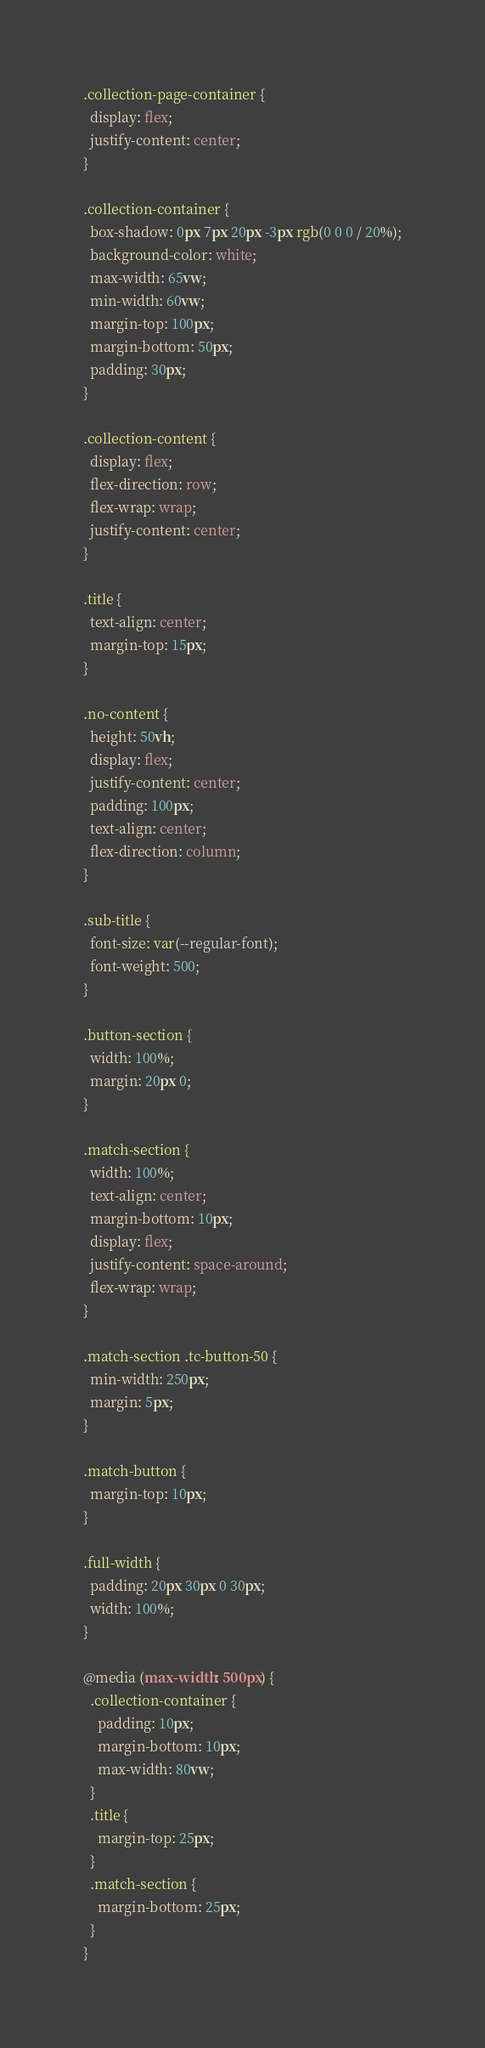<code> <loc_0><loc_0><loc_500><loc_500><_CSS_>.collection-page-container {
  display: flex;
  justify-content: center;
}

.collection-container {
  box-shadow: 0px 7px 20px -3px rgb(0 0 0 / 20%);
  background-color: white;
  max-width: 65vw;
  min-width: 60vw;
  margin-top: 100px;
  margin-bottom: 50px;
  padding: 30px;
}

.collection-content {
  display: flex;
  flex-direction: row;
  flex-wrap: wrap;
  justify-content: center;
}

.title {
  text-align: center;
  margin-top: 15px;
}

.no-content {
  height: 50vh;
  display: flex;
  justify-content: center;
  padding: 100px;
  text-align: center;
  flex-direction: column;
}

.sub-title {
  font-size: var(--regular-font);
  font-weight: 500;
}

.button-section {
  width: 100%;
  margin: 20px 0;
}

.match-section {
  width: 100%;
  text-align: center;
  margin-bottom: 10px;
  display: flex;
  justify-content: space-around;
  flex-wrap: wrap;
}

.match-section .tc-button-50 {
  min-width: 250px;
  margin: 5px;
}

.match-button {
  margin-top: 10px;
}

.full-width {
  padding: 20px 30px 0 30px;
  width: 100%;
}

@media (max-width: 500px) {
  .collection-container {
    padding: 10px;
    margin-bottom: 10px;
    max-width: 80vw;
  }
  .title {
    margin-top: 25px;
  }
  .match-section {
    margin-bottom: 25px;
  }
}
</code> 